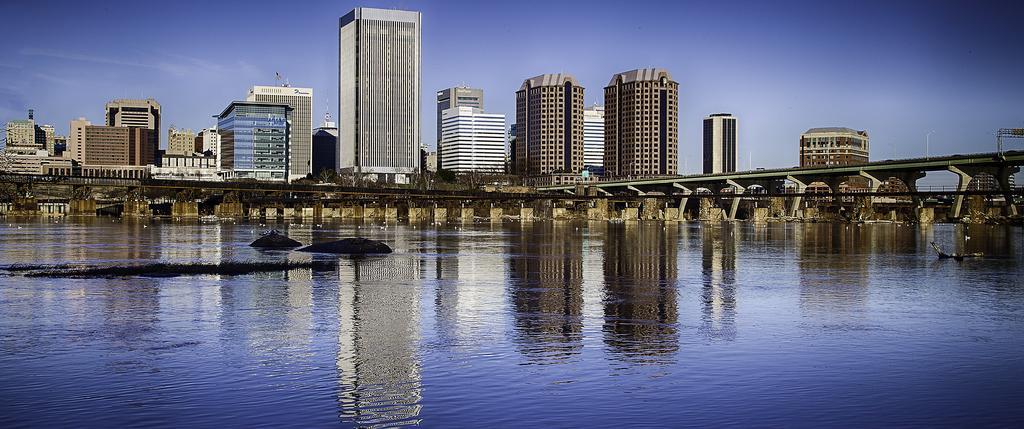Can you describe this image briefly? In the image I can see a lake on which there is a bridge and around there are some buildings, houses and some other things. 